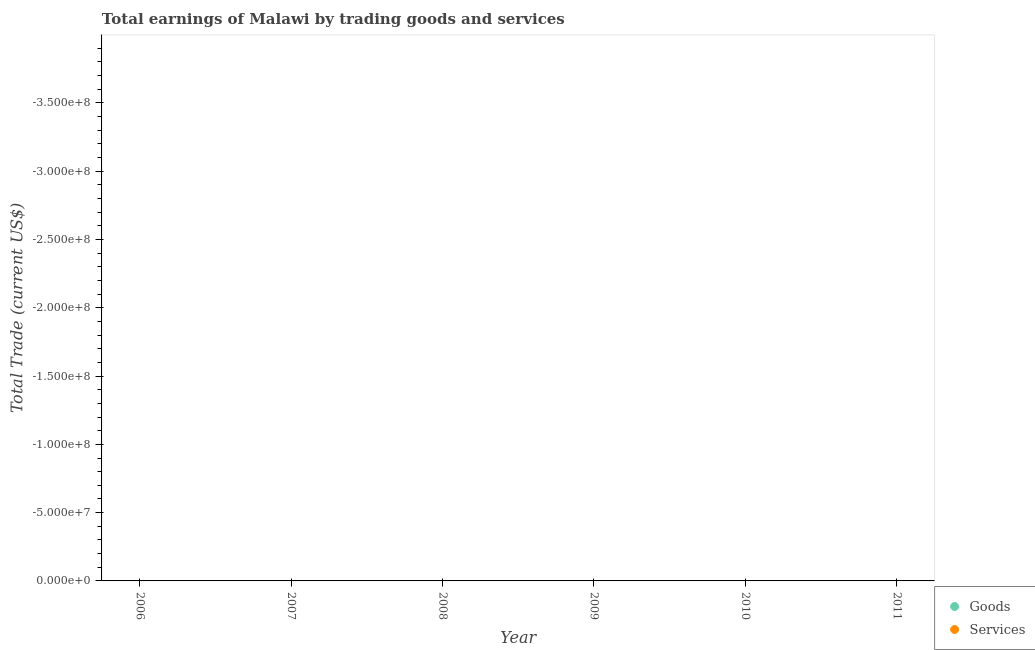How many different coloured dotlines are there?
Your response must be concise. 0. Is the number of dotlines equal to the number of legend labels?
Your answer should be compact. No. What is the amount earned by trading goods in 2006?
Keep it short and to the point. 0. Across all years, what is the minimum amount earned by trading services?
Ensure brevity in your answer.  0. What is the total amount earned by trading goods in the graph?
Ensure brevity in your answer.  0. In how many years, is the amount earned by trading services greater than -30000000 US$?
Your answer should be compact. 0. In how many years, is the amount earned by trading goods greater than the average amount earned by trading goods taken over all years?
Your answer should be very brief. 0. Does the amount earned by trading services monotonically increase over the years?
Make the answer very short. No. Is the amount earned by trading goods strictly less than the amount earned by trading services over the years?
Give a very brief answer. No. What is the difference between two consecutive major ticks on the Y-axis?
Keep it short and to the point. 5.00e+07. Are the values on the major ticks of Y-axis written in scientific E-notation?
Give a very brief answer. Yes. How many legend labels are there?
Provide a short and direct response. 2. How are the legend labels stacked?
Your response must be concise. Vertical. What is the title of the graph?
Provide a succinct answer. Total earnings of Malawi by trading goods and services. Does "Investment in Telecom" appear as one of the legend labels in the graph?
Your answer should be very brief. No. What is the label or title of the Y-axis?
Make the answer very short. Total Trade (current US$). What is the Total Trade (current US$) in Services in 2006?
Ensure brevity in your answer.  0. What is the Total Trade (current US$) in Goods in 2007?
Your answer should be very brief. 0. What is the Total Trade (current US$) in Goods in 2008?
Your response must be concise. 0. What is the Total Trade (current US$) in Services in 2008?
Your answer should be compact. 0. What is the Total Trade (current US$) in Services in 2009?
Your answer should be very brief. 0. What is the Total Trade (current US$) in Goods in 2010?
Give a very brief answer. 0. What is the Total Trade (current US$) of Services in 2010?
Provide a short and direct response. 0. 